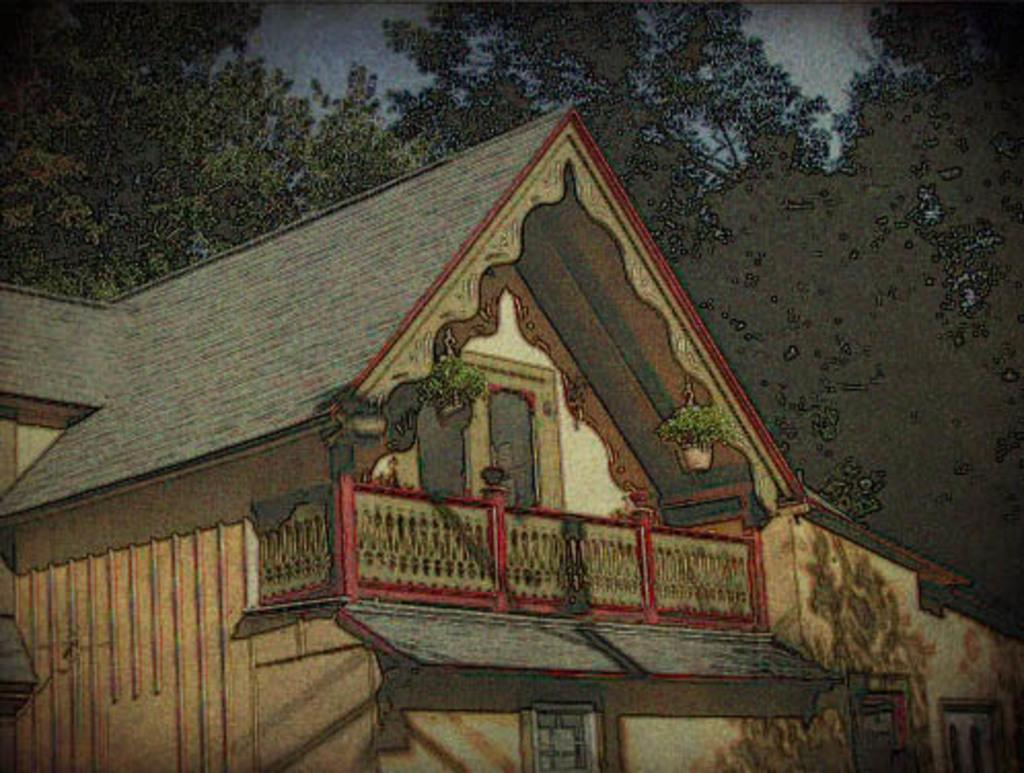What is the main subject in the center of the image? There is a house in the center of the image. What can be seen in the background of the image? There are trees in the background of the image. What color is the beam used for painting the house in the image? There is no mention of a beam or painting in the image; it simply shows a house and trees in the background. 